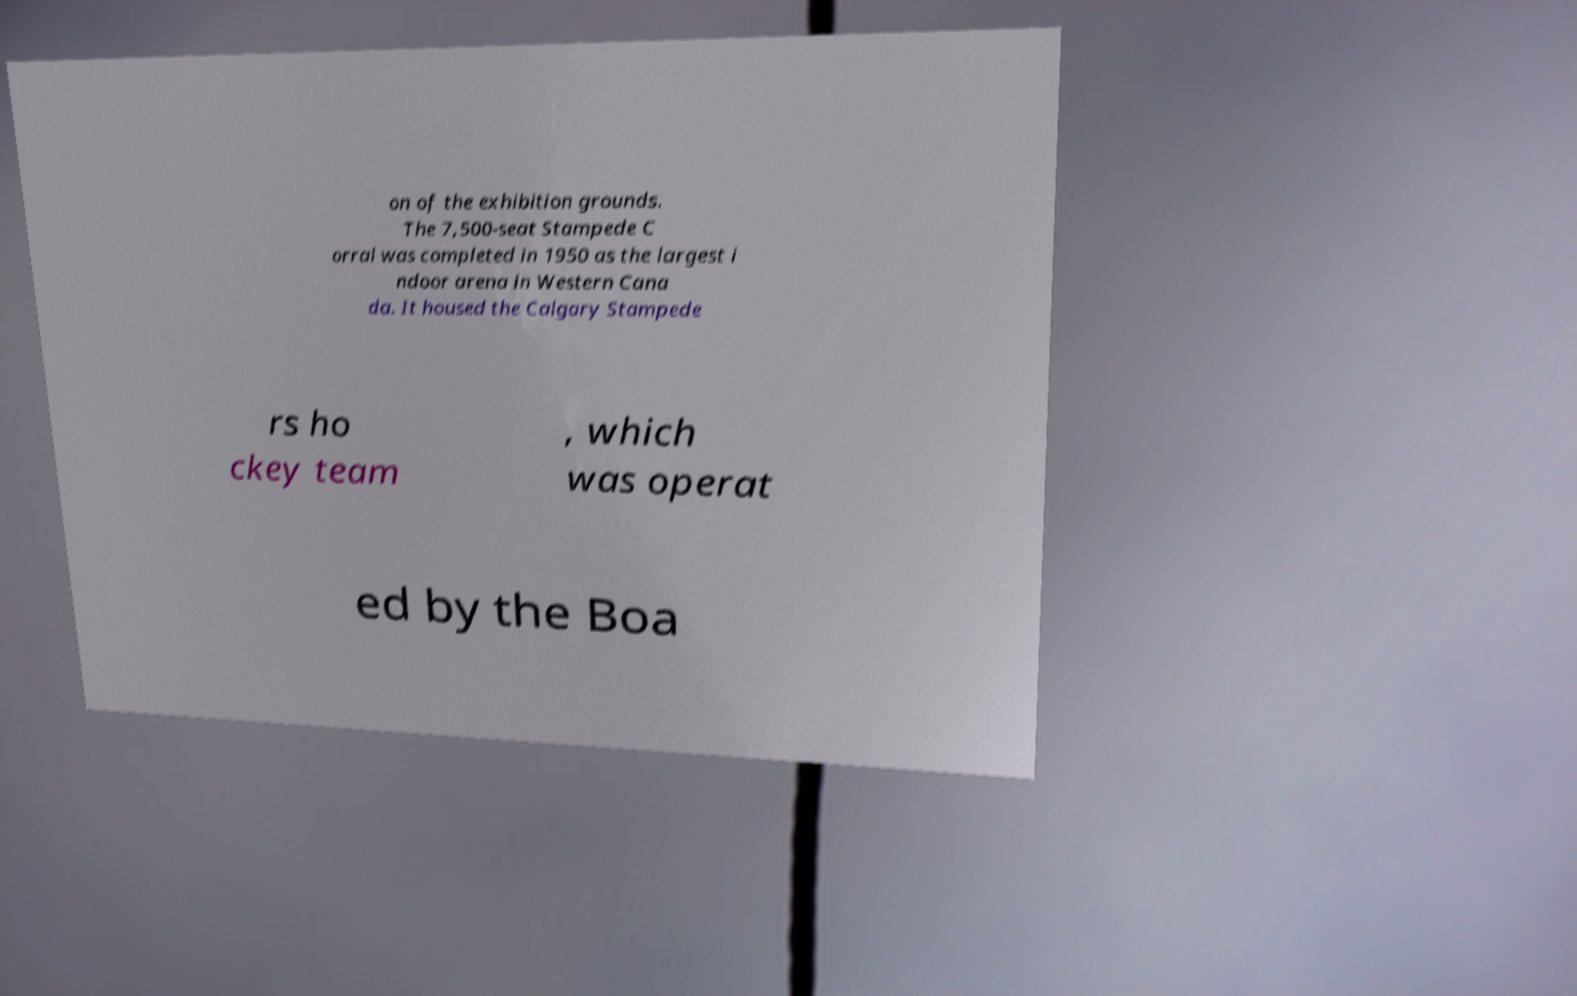Please read and relay the text visible in this image. What does it say? on of the exhibition grounds. The 7,500-seat Stampede C orral was completed in 1950 as the largest i ndoor arena in Western Cana da. It housed the Calgary Stampede rs ho ckey team , which was operat ed by the Boa 